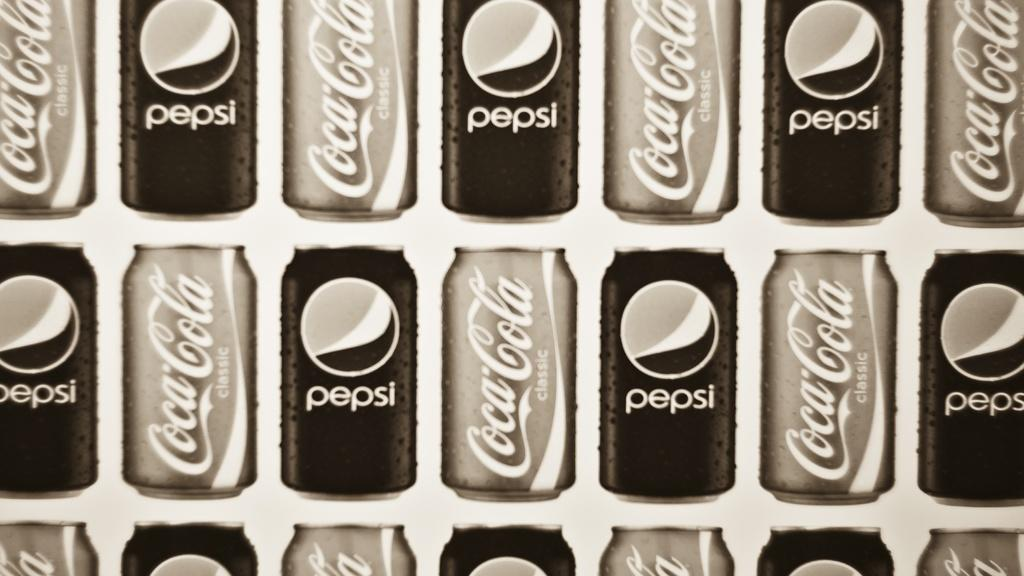What type of beverage cans are present in the image? There is a Pepsi can and a Coca Cola can in the image. What representative from the land of disgust is present in the image? There is no representative from the land of disgust present in the image; it only features Pepsi and Coca Cola cans. 